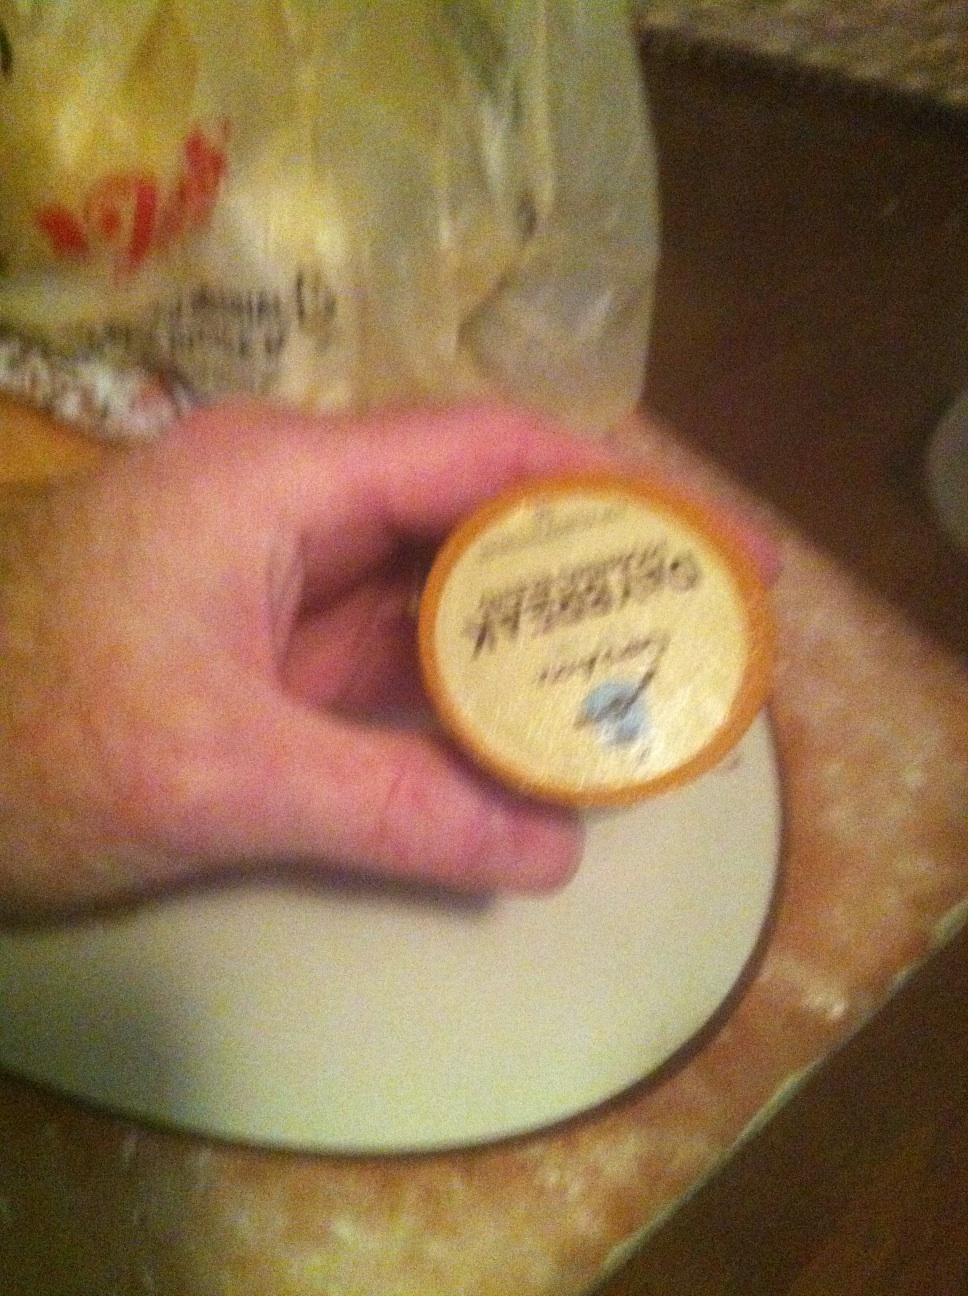Can you identify the brand of this coffee pod? From the image, it looks like the brand might be 'Donut House'. The text is a bit blurry, so it is hard to tell for certain. What other information can you infer from the image about this coffee pod? Based on the image, the coffee pod appears to be part of a single-serve system, likely compatible with a Keurig machine. These coffee pods often offer a variety of flavors, ranging from classic roasts to flavored options. The packaging design is simple and the color scheme hints at a possibly mild or medium roast flavor. Additionally, the 'Donut House' branding typically suggests a rich, traditional coffee flavor that pairs well with donuts and breakfast foods. Imagine you were to use this coffee pod in the morning. Describe the potential setting and experience in detail. Imagine waking up on a serene Sunday morning. The sunlight gently filters through your kitchen window, casting a warm glow on your surroundings. You reach for the coffee pod and place it in your Keurig machine, eagerly waiting for the comforting aroma of freshly brewed coffee to fill the air. As the machine hums to life, you prepare a hearty breakfast—scrambled eggs, crispy bacon, and buttered toast. The coffee maker finally signals that your drink is ready; you pour the steaming coffee into your favorite mug. The rich scent of 'Donut House' blend wafts up, promising a smooth, satisfying flavor. You take a sip and relish the warm, soothing taste that perfectly complements your morning meal. 